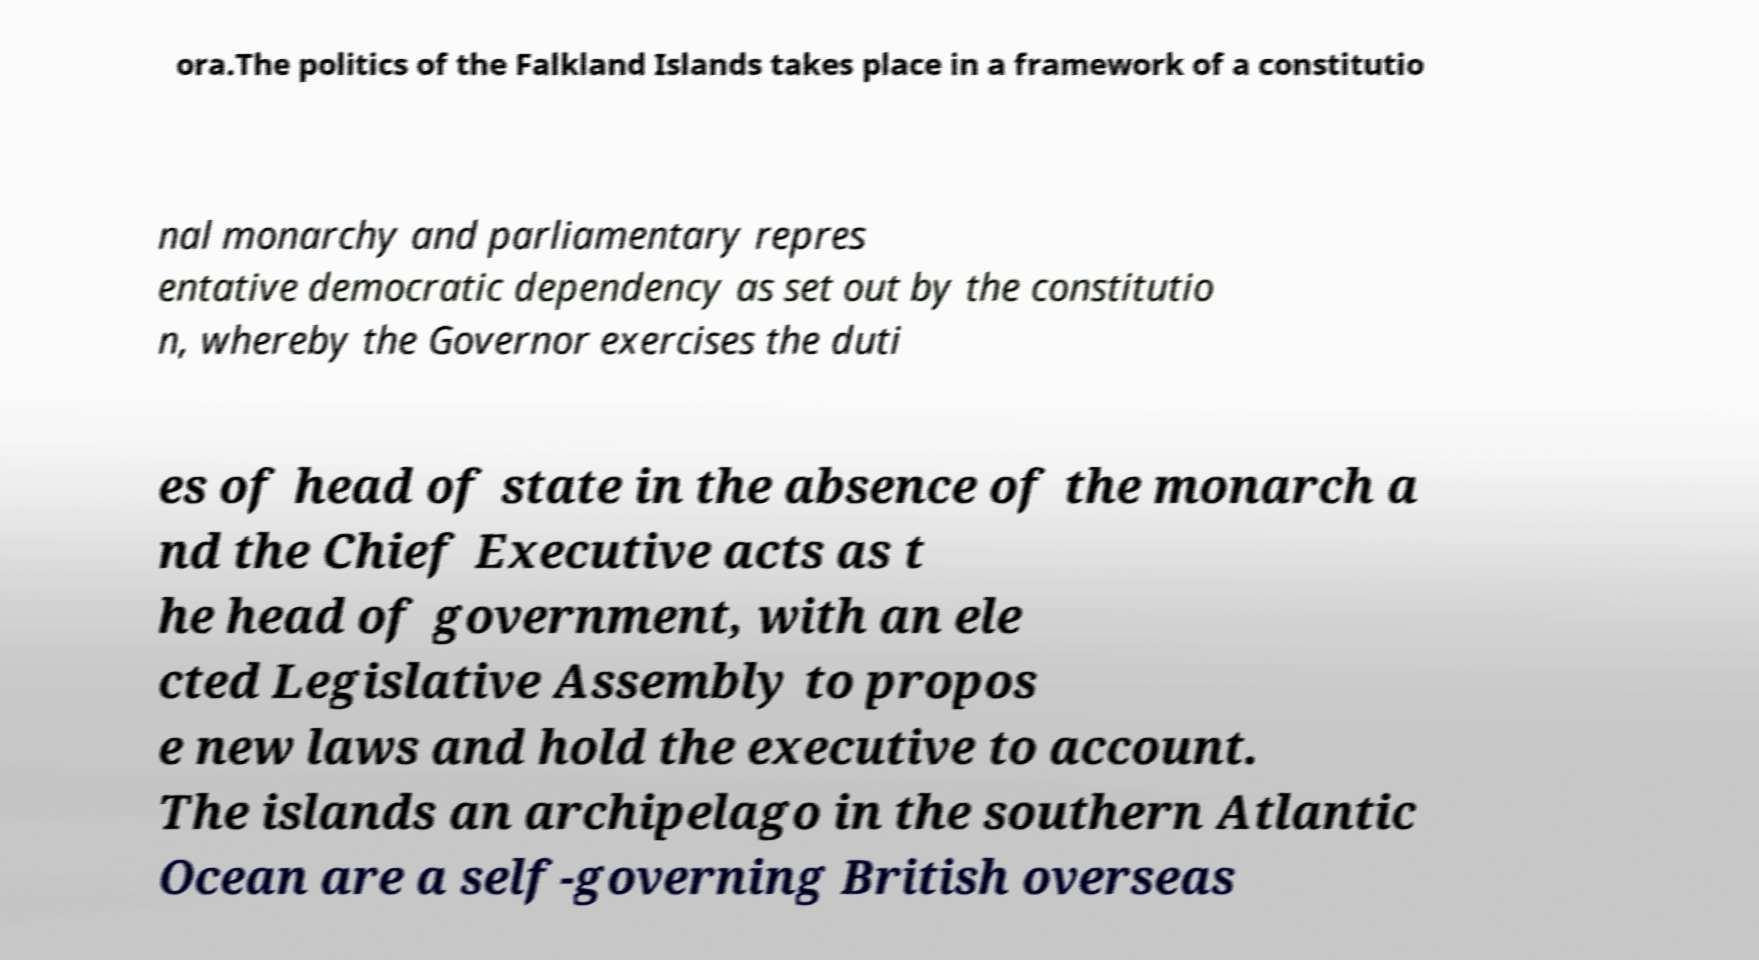There's text embedded in this image that I need extracted. Can you transcribe it verbatim? ora.The politics of the Falkland Islands takes place in a framework of a constitutio nal monarchy and parliamentary repres entative democratic dependency as set out by the constitutio n, whereby the Governor exercises the duti es of head of state in the absence of the monarch a nd the Chief Executive acts as t he head of government, with an ele cted Legislative Assembly to propos e new laws and hold the executive to account. The islands an archipelago in the southern Atlantic Ocean are a self-governing British overseas 